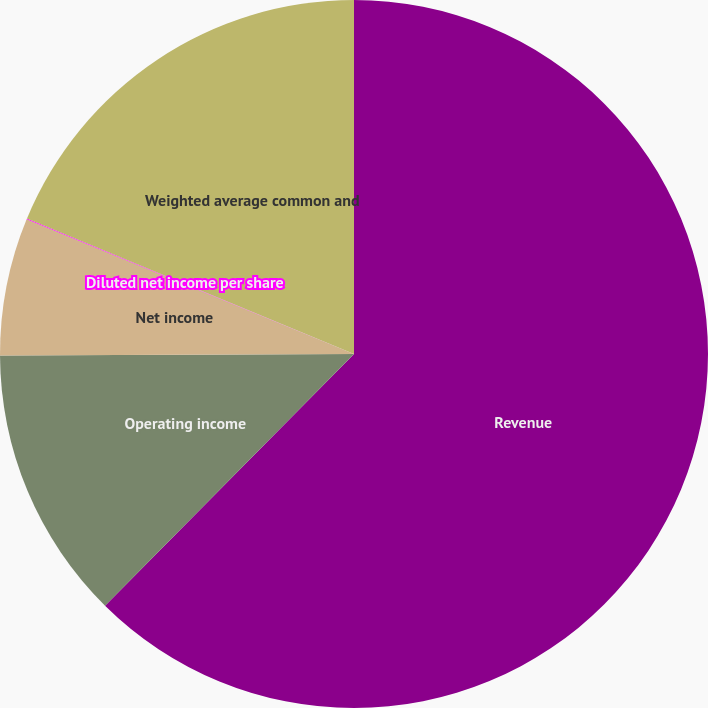<chart> <loc_0><loc_0><loc_500><loc_500><pie_chart><fcel>Revenue<fcel>Operating income<fcel>Net income<fcel>Diluted net income per share<fcel>Weighted average common and<nl><fcel>62.42%<fcel>12.52%<fcel>6.28%<fcel>0.04%<fcel>18.75%<nl></chart> 